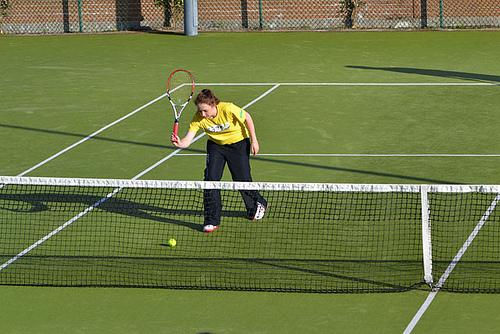Identify the colors and key features of the tennis racket in the image. The tennis racket is red, white, and black with an orange and white handle. What is the person on the tennis court doing, and what are they wearing? The person on the tennis court is a woman playing tennis, wearing a yellow t-shirt, black pants, and white tennis shoes. List the colors and features of the tennis ball. The tennis ball is bright green and it is located on the ground. If you were advertising this tennis court, what phrases would you use to describe its visual appeal? Picturesque green grass court, spacious playing area, and a crisp white tennis net for an enticing game experience. Describe the attire of the woman playing tennis in the image. The woman is wearing a yellow t-shirt with a logo, black jogging pants, and white tennis shoes. What is the predominant color of the tennis court and what type of court is it? The tennis court is predominantly green and it is a grass tennis court. What is the position of the tennis ball in relation to the net? The tennis ball is on the ground behind the net. Select an object from the image and describe its relationship to other objects in the scene. A tennis net on a tennis court is surrounded by a green grass playing area, a white line of the court, and a woman holding a tennis racket. 